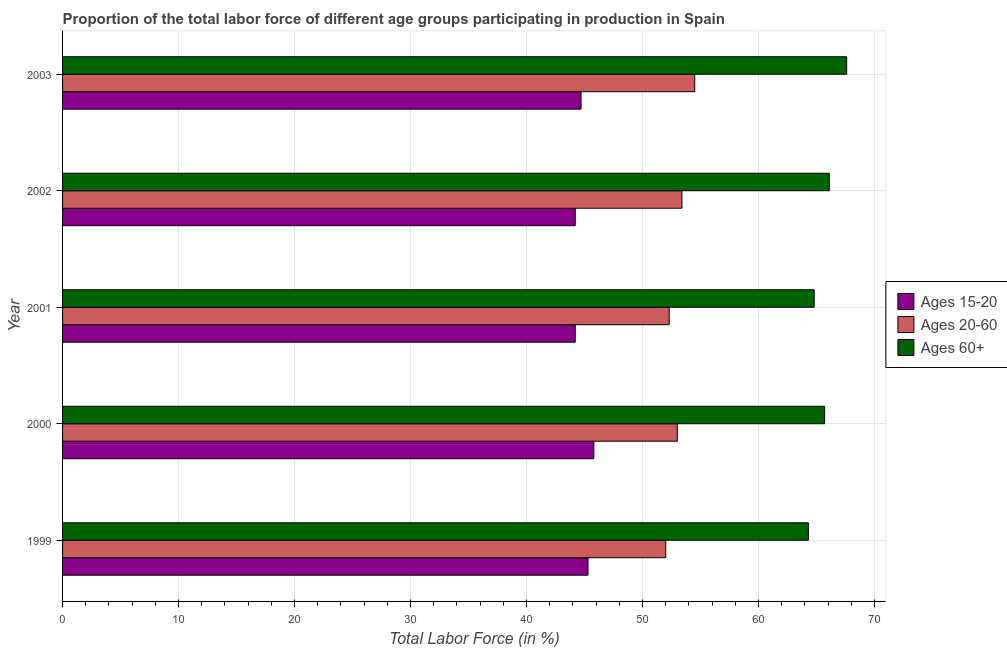Are the number of bars on each tick of the Y-axis equal?
Give a very brief answer. Yes. How many bars are there on the 4th tick from the bottom?
Give a very brief answer. 3. What is the percentage of labor force within the age group 15-20 in 1999?
Provide a short and direct response. 45.3. Across all years, what is the maximum percentage of labor force within the age group 15-20?
Make the answer very short. 45.8. Across all years, what is the minimum percentage of labor force above age 60?
Your answer should be very brief. 64.3. In which year was the percentage of labor force above age 60 maximum?
Your response must be concise. 2003. What is the total percentage of labor force within the age group 15-20 in the graph?
Make the answer very short. 224.2. What is the difference between the percentage of labor force within the age group 15-20 in 2000 and that in 2003?
Offer a terse response. 1.1. What is the average percentage of labor force within the age group 15-20 per year?
Keep it short and to the point. 44.84. What is the ratio of the percentage of labor force within the age group 15-20 in 2000 to that in 2003?
Your response must be concise. 1.02. Is the percentage of labor force within the age group 15-20 in 2000 less than that in 2002?
Make the answer very short. No. Is the difference between the percentage of labor force within the age group 20-60 in 2002 and 2003 greater than the difference between the percentage of labor force within the age group 15-20 in 2002 and 2003?
Offer a terse response. No. What is the difference between the highest and the lowest percentage of labor force above age 60?
Provide a succinct answer. 3.3. Is the sum of the percentage of labor force within the age group 15-20 in 1999 and 2002 greater than the maximum percentage of labor force within the age group 20-60 across all years?
Provide a succinct answer. Yes. What does the 3rd bar from the top in 1999 represents?
Ensure brevity in your answer.  Ages 15-20. What does the 1st bar from the bottom in 2003 represents?
Offer a terse response. Ages 15-20. Are all the bars in the graph horizontal?
Make the answer very short. Yes. What is the difference between two consecutive major ticks on the X-axis?
Provide a short and direct response. 10. Are the values on the major ticks of X-axis written in scientific E-notation?
Your answer should be compact. No. Does the graph contain grids?
Offer a terse response. Yes. How are the legend labels stacked?
Offer a very short reply. Vertical. What is the title of the graph?
Your answer should be compact. Proportion of the total labor force of different age groups participating in production in Spain. What is the label or title of the Y-axis?
Provide a short and direct response. Year. What is the Total Labor Force (in %) in Ages 15-20 in 1999?
Your answer should be very brief. 45.3. What is the Total Labor Force (in %) in Ages 20-60 in 1999?
Offer a terse response. 52. What is the Total Labor Force (in %) in Ages 60+ in 1999?
Offer a terse response. 64.3. What is the Total Labor Force (in %) of Ages 15-20 in 2000?
Your response must be concise. 45.8. What is the Total Labor Force (in %) in Ages 20-60 in 2000?
Provide a succinct answer. 53. What is the Total Labor Force (in %) of Ages 60+ in 2000?
Keep it short and to the point. 65.7. What is the Total Labor Force (in %) of Ages 15-20 in 2001?
Your answer should be very brief. 44.2. What is the Total Labor Force (in %) in Ages 20-60 in 2001?
Make the answer very short. 52.3. What is the Total Labor Force (in %) in Ages 60+ in 2001?
Keep it short and to the point. 64.8. What is the Total Labor Force (in %) of Ages 15-20 in 2002?
Your response must be concise. 44.2. What is the Total Labor Force (in %) in Ages 20-60 in 2002?
Give a very brief answer. 53.4. What is the Total Labor Force (in %) in Ages 60+ in 2002?
Offer a terse response. 66.1. What is the Total Labor Force (in %) of Ages 15-20 in 2003?
Give a very brief answer. 44.7. What is the Total Labor Force (in %) in Ages 20-60 in 2003?
Provide a short and direct response. 54.5. What is the Total Labor Force (in %) in Ages 60+ in 2003?
Provide a succinct answer. 67.6. Across all years, what is the maximum Total Labor Force (in %) of Ages 15-20?
Your answer should be very brief. 45.8. Across all years, what is the maximum Total Labor Force (in %) of Ages 20-60?
Keep it short and to the point. 54.5. Across all years, what is the maximum Total Labor Force (in %) of Ages 60+?
Your answer should be compact. 67.6. Across all years, what is the minimum Total Labor Force (in %) of Ages 15-20?
Your response must be concise. 44.2. Across all years, what is the minimum Total Labor Force (in %) of Ages 60+?
Keep it short and to the point. 64.3. What is the total Total Labor Force (in %) of Ages 15-20 in the graph?
Offer a terse response. 224.2. What is the total Total Labor Force (in %) of Ages 20-60 in the graph?
Your answer should be compact. 265.2. What is the total Total Labor Force (in %) in Ages 60+ in the graph?
Ensure brevity in your answer.  328.5. What is the difference between the Total Labor Force (in %) of Ages 15-20 in 1999 and that in 2000?
Provide a short and direct response. -0.5. What is the difference between the Total Labor Force (in %) of Ages 60+ in 1999 and that in 2000?
Make the answer very short. -1.4. What is the difference between the Total Labor Force (in %) in Ages 15-20 in 1999 and that in 2001?
Your answer should be very brief. 1.1. What is the difference between the Total Labor Force (in %) in Ages 20-60 in 1999 and that in 2001?
Provide a succinct answer. -0.3. What is the difference between the Total Labor Force (in %) of Ages 15-20 in 1999 and that in 2002?
Your answer should be very brief. 1.1. What is the difference between the Total Labor Force (in %) in Ages 60+ in 1999 and that in 2002?
Provide a short and direct response. -1.8. What is the difference between the Total Labor Force (in %) in Ages 20-60 in 1999 and that in 2003?
Give a very brief answer. -2.5. What is the difference between the Total Labor Force (in %) of Ages 60+ in 1999 and that in 2003?
Keep it short and to the point. -3.3. What is the difference between the Total Labor Force (in %) of Ages 15-20 in 2000 and that in 2001?
Your response must be concise. 1.6. What is the difference between the Total Labor Force (in %) of Ages 20-60 in 2000 and that in 2001?
Provide a succinct answer. 0.7. What is the difference between the Total Labor Force (in %) of Ages 60+ in 2000 and that in 2001?
Provide a short and direct response. 0.9. What is the difference between the Total Labor Force (in %) in Ages 15-20 in 2000 and that in 2002?
Your answer should be compact. 1.6. What is the difference between the Total Labor Force (in %) of Ages 60+ in 2000 and that in 2002?
Provide a succinct answer. -0.4. What is the difference between the Total Labor Force (in %) of Ages 60+ in 2000 and that in 2003?
Provide a short and direct response. -1.9. What is the difference between the Total Labor Force (in %) of Ages 15-20 in 2001 and that in 2002?
Provide a short and direct response. 0. What is the difference between the Total Labor Force (in %) in Ages 20-60 in 2001 and that in 2002?
Keep it short and to the point. -1.1. What is the difference between the Total Labor Force (in %) in Ages 60+ in 2001 and that in 2002?
Ensure brevity in your answer.  -1.3. What is the difference between the Total Labor Force (in %) in Ages 60+ in 2001 and that in 2003?
Your answer should be very brief. -2.8. What is the difference between the Total Labor Force (in %) of Ages 15-20 in 2002 and that in 2003?
Ensure brevity in your answer.  -0.5. What is the difference between the Total Labor Force (in %) of Ages 60+ in 2002 and that in 2003?
Provide a succinct answer. -1.5. What is the difference between the Total Labor Force (in %) of Ages 15-20 in 1999 and the Total Labor Force (in %) of Ages 20-60 in 2000?
Make the answer very short. -7.7. What is the difference between the Total Labor Force (in %) in Ages 15-20 in 1999 and the Total Labor Force (in %) in Ages 60+ in 2000?
Offer a terse response. -20.4. What is the difference between the Total Labor Force (in %) of Ages 20-60 in 1999 and the Total Labor Force (in %) of Ages 60+ in 2000?
Provide a short and direct response. -13.7. What is the difference between the Total Labor Force (in %) in Ages 15-20 in 1999 and the Total Labor Force (in %) in Ages 60+ in 2001?
Offer a very short reply. -19.5. What is the difference between the Total Labor Force (in %) of Ages 15-20 in 1999 and the Total Labor Force (in %) of Ages 20-60 in 2002?
Your answer should be compact. -8.1. What is the difference between the Total Labor Force (in %) in Ages 15-20 in 1999 and the Total Labor Force (in %) in Ages 60+ in 2002?
Make the answer very short. -20.8. What is the difference between the Total Labor Force (in %) of Ages 20-60 in 1999 and the Total Labor Force (in %) of Ages 60+ in 2002?
Make the answer very short. -14.1. What is the difference between the Total Labor Force (in %) in Ages 15-20 in 1999 and the Total Labor Force (in %) in Ages 20-60 in 2003?
Your answer should be very brief. -9.2. What is the difference between the Total Labor Force (in %) of Ages 15-20 in 1999 and the Total Labor Force (in %) of Ages 60+ in 2003?
Keep it short and to the point. -22.3. What is the difference between the Total Labor Force (in %) in Ages 20-60 in 1999 and the Total Labor Force (in %) in Ages 60+ in 2003?
Make the answer very short. -15.6. What is the difference between the Total Labor Force (in %) in Ages 15-20 in 2000 and the Total Labor Force (in %) in Ages 20-60 in 2001?
Provide a short and direct response. -6.5. What is the difference between the Total Labor Force (in %) in Ages 15-20 in 2000 and the Total Labor Force (in %) in Ages 60+ in 2001?
Your answer should be compact. -19. What is the difference between the Total Labor Force (in %) of Ages 15-20 in 2000 and the Total Labor Force (in %) of Ages 60+ in 2002?
Provide a short and direct response. -20.3. What is the difference between the Total Labor Force (in %) in Ages 20-60 in 2000 and the Total Labor Force (in %) in Ages 60+ in 2002?
Offer a very short reply. -13.1. What is the difference between the Total Labor Force (in %) in Ages 15-20 in 2000 and the Total Labor Force (in %) in Ages 20-60 in 2003?
Offer a very short reply. -8.7. What is the difference between the Total Labor Force (in %) of Ages 15-20 in 2000 and the Total Labor Force (in %) of Ages 60+ in 2003?
Ensure brevity in your answer.  -21.8. What is the difference between the Total Labor Force (in %) in Ages 20-60 in 2000 and the Total Labor Force (in %) in Ages 60+ in 2003?
Your answer should be very brief. -14.6. What is the difference between the Total Labor Force (in %) in Ages 15-20 in 2001 and the Total Labor Force (in %) in Ages 60+ in 2002?
Make the answer very short. -21.9. What is the difference between the Total Labor Force (in %) of Ages 20-60 in 2001 and the Total Labor Force (in %) of Ages 60+ in 2002?
Give a very brief answer. -13.8. What is the difference between the Total Labor Force (in %) in Ages 15-20 in 2001 and the Total Labor Force (in %) in Ages 60+ in 2003?
Provide a succinct answer. -23.4. What is the difference between the Total Labor Force (in %) in Ages 20-60 in 2001 and the Total Labor Force (in %) in Ages 60+ in 2003?
Give a very brief answer. -15.3. What is the difference between the Total Labor Force (in %) in Ages 15-20 in 2002 and the Total Labor Force (in %) in Ages 20-60 in 2003?
Ensure brevity in your answer.  -10.3. What is the difference between the Total Labor Force (in %) of Ages 15-20 in 2002 and the Total Labor Force (in %) of Ages 60+ in 2003?
Your response must be concise. -23.4. What is the average Total Labor Force (in %) of Ages 15-20 per year?
Give a very brief answer. 44.84. What is the average Total Labor Force (in %) of Ages 20-60 per year?
Ensure brevity in your answer.  53.04. What is the average Total Labor Force (in %) in Ages 60+ per year?
Provide a succinct answer. 65.7. In the year 1999, what is the difference between the Total Labor Force (in %) of Ages 15-20 and Total Labor Force (in %) of Ages 20-60?
Give a very brief answer. -6.7. In the year 1999, what is the difference between the Total Labor Force (in %) of Ages 15-20 and Total Labor Force (in %) of Ages 60+?
Offer a terse response. -19. In the year 1999, what is the difference between the Total Labor Force (in %) in Ages 20-60 and Total Labor Force (in %) in Ages 60+?
Your response must be concise. -12.3. In the year 2000, what is the difference between the Total Labor Force (in %) in Ages 15-20 and Total Labor Force (in %) in Ages 20-60?
Your answer should be compact. -7.2. In the year 2000, what is the difference between the Total Labor Force (in %) of Ages 15-20 and Total Labor Force (in %) of Ages 60+?
Provide a succinct answer. -19.9. In the year 2000, what is the difference between the Total Labor Force (in %) in Ages 20-60 and Total Labor Force (in %) in Ages 60+?
Ensure brevity in your answer.  -12.7. In the year 2001, what is the difference between the Total Labor Force (in %) in Ages 15-20 and Total Labor Force (in %) in Ages 60+?
Your answer should be compact. -20.6. In the year 2001, what is the difference between the Total Labor Force (in %) of Ages 20-60 and Total Labor Force (in %) of Ages 60+?
Provide a short and direct response. -12.5. In the year 2002, what is the difference between the Total Labor Force (in %) in Ages 15-20 and Total Labor Force (in %) in Ages 20-60?
Keep it short and to the point. -9.2. In the year 2002, what is the difference between the Total Labor Force (in %) in Ages 15-20 and Total Labor Force (in %) in Ages 60+?
Provide a short and direct response. -21.9. In the year 2002, what is the difference between the Total Labor Force (in %) in Ages 20-60 and Total Labor Force (in %) in Ages 60+?
Your answer should be compact. -12.7. In the year 2003, what is the difference between the Total Labor Force (in %) of Ages 15-20 and Total Labor Force (in %) of Ages 20-60?
Keep it short and to the point. -9.8. In the year 2003, what is the difference between the Total Labor Force (in %) of Ages 15-20 and Total Labor Force (in %) of Ages 60+?
Your answer should be very brief. -22.9. What is the ratio of the Total Labor Force (in %) in Ages 15-20 in 1999 to that in 2000?
Give a very brief answer. 0.99. What is the ratio of the Total Labor Force (in %) of Ages 20-60 in 1999 to that in 2000?
Ensure brevity in your answer.  0.98. What is the ratio of the Total Labor Force (in %) in Ages 60+ in 1999 to that in 2000?
Provide a succinct answer. 0.98. What is the ratio of the Total Labor Force (in %) of Ages 15-20 in 1999 to that in 2001?
Give a very brief answer. 1.02. What is the ratio of the Total Labor Force (in %) in Ages 20-60 in 1999 to that in 2001?
Provide a succinct answer. 0.99. What is the ratio of the Total Labor Force (in %) of Ages 60+ in 1999 to that in 2001?
Provide a short and direct response. 0.99. What is the ratio of the Total Labor Force (in %) of Ages 15-20 in 1999 to that in 2002?
Your answer should be compact. 1.02. What is the ratio of the Total Labor Force (in %) of Ages 20-60 in 1999 to that in 2002?
Your response must be concise. 0.97. What is the ratio of the Total Labor Force (in %) of Ages 60+ in 1999 to that in 2002?
Make the answer very short. 0.97. What is the ratio of the Total Labor Force (in %) of Ages 15-20 in 1999 to that in 2003?
Your response must be concise. 1.01. What is the ratio of the Total Labor Force (in %) of Ages 20-60 in 1999 to that in 2003?
Give a very brief answer. 0.95. What is the ratio of the Total Labor Force (in %) in Ages 60+ in 1999 to that in 2003?
Offer a very short reply. 0.95. What is the ratio of the Total Labor Force (in %) in Ages 15-20 in 2000 to that in 2001?
Your answer should be very brief. 1.04. What is the ratio of the Total Labor Force (in %) in Ages 20-60 in 2000 to that in 2001?
Offer a terse response. 1.01. What is the ratio of the Total Labor Force (in %) of Ages 60+ in 2000 to that in 2001?
Keep it short and to the point. 1.01. What is the ratio of the Total Labor Force (in %) of Ages 15-20 in 2000 to that in 2002?
Offer a very short reply. 1.04. What is the ratio of the Total Labor Force (in %) in Ages 60+ in 2000 to that in 2002?
Ensure brevity in your answer.  0.99. What is the ratio of the Total Labor Force (in %) in Ages 15-20 in 2000 to that in 2003?
Ensure brevity in your answer.  1.02. What is the ratio of the Total Labor Force (in %) in Ages 20-60 in 2000 to that in 2003?
Your answer should be very brief. 0.97. What is the ratio of the Total Labor Force (in %) of Ages 60+ in 2000 to that in 2003?
Offer a terse response. 0.97. What is the ratio of the Total Labor Force (in %) in Ages 15-20 in 2001 to that in 2002?
Provide a succinct answer. 1. What is the ratio of the Total Labor Force (in %) of Ages 20-60 in 2001 to that in 2002?
Give a very brief answer. 0.98. What is the ratio of the Total Labor Force (in %) in Ages 60+ in 2001 to that in 2002?
Keep it short and to the point. 0.98. What is the ratio of the Total Labor Force (in %) in Ages 20-60 in 2001 to that in 2003?
Provide a short and direct response. 0.96. What is the ratio of the Total Labor Force (in %) of Ages 60+ in 2001 to that in 2003?
Provide a succinct answer. 0.96. What is the ratio of the Total Labor Force (in %) in Ages 20-60 in 2002 to that in 2003?
Make the answer very short. 0.98. What is the ratio of the Total Labor Force (in %) in Ages 60+ in 2002 to that in 2003?
Provide a succinct answer. 0.98. What is the difference between the highest and the second highest Total Labor Force (in %) in Ages 15-20?
Provide a succinct answer. 0.5. What is the difference between the highest and the lowest Total Labor Force (in %) of Ages 15-20?
Your response must be concise. 1.6. What is the difference between the highest and the lowest Total Labor Force (in %) of Ages 60+?
Your response must be concise. 3.3. 